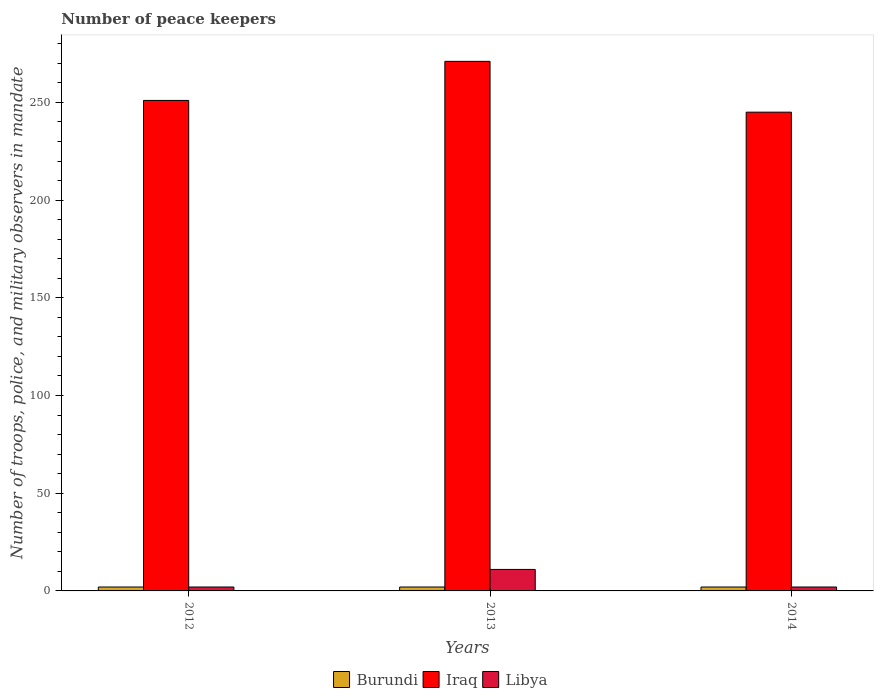How many different coloured bars are there?
Provide a short and direct response. 3. Are the number of bars per tick equal to the number of legend labels?
Ensure brevity in your answer.  Yes. In how many cases, is the number of bars for a given year not equal to the number of legend labels?
Keep it short and to the point. 0. What is the number of peace keepers in in Iraq in 2012?
Offer a very short reply. 251. Across all years, what is the maximum number of peace keepers in in Burundi?
Offer a very short reply. 2. Across all years, what is the minimum number of peace keepers in in Burundi?
Provide a succinct answer. 2. What is the average number of peace keepers in in Burundi per year?
Your response must be concise. 2. In the year 2013, what is the difference between the number of peace keepers in in Iraq and number of peace keepers in in Burundi?
Give a very brief answer. 269. In how many years, is the number of peace keepers in in Libya greater than 20?
Keep it short and to the point. 0. What is the ratio of the number of peace keepers in in Iraq in 2013 to that in 2014?
Give a very brief answer. 1.11. What is the difference between the highest and the second highest number of peace keepers in in Iraq?
Make the answer very short. 20. In how many years, is the number of peace keepers in in Burundi greater than the average number of peace keepers in in Burundi taken over all years?
Your response must be concise. 0. What does the 3rd bar from the left in 2014 represents?
Provide a short and direct response. Libya. What does the 3rd bar from the right in 2014 represents?
Your response must be concise. Burundi. Is it the case that in every year, the sum of the number of peace keepers in in Libya and number of peace keepers in in Burundi is greater than the number of peace keepers in in Iraq?
Provide a short and direct response. No. How many bars are there?
Ensure brevity in your answer.  9. Are all the bars in the graph horizontal?
Ensure brevity in your answer.  No. What is the difference between two consecutive major ticks on the Y-axis?
Provide a short and direct response. 50. Does the graph contain grids?
Provide a succinct answer. No. Where does the legend appear in the graph?
Ensure brevity in your answer.  Bottom center. How many legend labels are there?
Offer a terse response. 3. What is the title of the graph?
Give a very brief answer. Number of peace keepers. What is the label or title of the X-axis?
Provide a succinct answer. Years. What is the label or title of the Y-axis?
Your answer should be very brief. Number of troops, police, and military observers in mandate. What is the Number of troops, police, and military observers in mandate in Burundi in 2012?
Offer a terse response. 2. What is the Number of troops, police, and military observers in mandate in Iraq in 2012?
Keep it short and to the point. 251. What is the Number of troops, police, and military observers in mandate in Burundi in 2013?
Provide a succinct answer. 2. What is the Number of troops, police, and military observers in mandate in Iraq in 2013?
Offer a very short reply. 271. What is the Number of troops, police, and military observers in mandate in Iraq in 2014?
Give a very brief answer. 245. Across all years, what is the maximum Number of troops, police, and military observers in mandate of Burundi?
Your answer should be very brief. 2. Across all years, what is the maximum Number of troops, police, and military observers in mandate of Iraq?
Provide a short and direct response. 271. Across all years, what is the minimum Number of troops, police, and military observers in mandate of Burundi?
Keep it short and to the point. 2. Across all years, what is the minimum Number of troops, police, and military observers in mandate of Iraq?
Make the answer very short. 245. Across all years, what is the minimum Number of troops, police, and military observers in mandate in Libya?
Your answer should be compact. 2. What is the total Number of troops, police, and military observers in mandate in Iraq in the graph?
Ensure brevity in your answer.  767. What is the difference between the Number of troops, police, and military observers in mandate in Iraq in 2012 and that in 2013?
Offer a very short reply. -20. What is the difference between the Number of troops, police, and military observers in mandate in Burundi in 2012 and that in 2014?
Give a very brief answer. 0. What is the difference between the Number of troops, police, and military observers in mandate of Libya in 2012 and that in 2014?
Your answer should be very brief. 0. What is the difference between the Number of troops, police, and military observers in mandate of Burundi in 2013 and that in 2014?
Provide a short and direct response. 0. What is the difference between the Number of troops, police, and military observers in mandate in Burundi in 2012 and the Number of troops, police, and military observers in mandate in Iraq in 2013?
Give a very brief answer. -269. What is the difference between the Number of troops, police, and military observers in mandate of Iraq in 2012 and the Number of troops, police, and military observers in mandate of Libya in 2013?
Your response must be concise. 240. What is the difference between the Number of troops, police, and military observers in mandate of Burundi in 2012 and the Number of troops, police, and military observers in mandate of Iraq in 2014?
Make the answer very short. -243. What is the difference between the Number of troops, police, and military observers in mandate in Iraq in 2012 and the Number of troops, police, and military observers in mandate in Libya in 2014?
Give a very brief answer. 249. What is the difference between the Number of troops, police, and military observers in mandate in Burundi in 2013 and the Number of troops, police, and military observers in mandate in Iraq in 2014?
Your answer should be very brief. -243. What is the difference between the Number of troops, police, and military observers in mandate in Iraq in 2013 and the Number of troops, police, and military observers in mandate in Libya in 2014?
Give a very brief answer. 269. What is the average Number of troops, police, and military observers in mandate of Burundi per year?
Offer a very short reply. 2. What is the average Number of troops, police, and military observers in mandate of Iraq per year?
Offer a very short reply. 255.67. In the year 2012, what is the difference between the Number of troops, police, and military observers in mandate of Burundi and Number of troops, police, and military observers in mandate of Iraq?
Your response must be concise. -249. In the year 2012, what is the difference between the Number of troops, police, and military observers in mandate of Iraq and Number of troops, police, and military observers in mandate of Libya?
Provide a short and direct response. 249. In the year 2013, what is the difference between the Number of troops, police, and military observers in mandate in Burundi and Number of troops, police, and military observers in mandate in Iraq?
Provide a succinct answer. -269. In the year 2013, what is the difference between the Number of troops, police, and military observers in mandate in Iraq and Number of troops, police, and military observers in mandate in Libya?
Offer a very short reply. 260. In the year 2014, what is the difference between the Number of troops, police, and military observers in mandate of Burundi and Number of troops, police, and military observers in mandate of Iraq?
Make the answer very short. -243. In the year 2014, what is the difference between the Number of troops, police, and military observers in mandate of Iraq and Number of troops, police, and military observers in mandate of Libya?
Your response must be concise. 243. What is the ratio of the Number of troops, police, and military observers in mandate in Iraq in 2012 to that in 2013?
Offer a very short reply. 0.93. What is the ratio of the Number of troops, police, and military observers in mandate in Libya in 2012 to that in 2013?
Offer a very short reply. 0.18. What is the ratio of the Number of troops, police, and military observers in mandate in Iraq in 2012 to that in 2014?
Provide a succinct answer. 1.02. What is the ratio of the Number of troops, police, and military observers in mandate of Burundi in 2013 to that in 2014?
Ensure brevity in your answer.  1. What is the ratio of the Number of troops, police, and military observers in mandate of Iraq in 2013 to that in 2014?
Provide a succinct answer. 1.11. What is the ratio of the Number of troops, police, and military observers in mandate of Libya in 2013 to that in 2014?
Provide a short and direct response. 5.5. What is the difference between the highest and the second highest Number of troops, police, and military observers in mandate in Burundi?
Your answer should be compact. 0. What is the difference between the highest and the second highest Number of troops, police, and military observers in mandate of Iraq?
Your response must be concise. 20. What is the difference between the highest and the second highest Number of troops, police, and military observers in mandate in Libya?
Your response must be concise. 9. What is the difference between the highest and the lowest Number of troops, police, and military observers in mandate in Libya?
Provide a short and direct response. 9. 